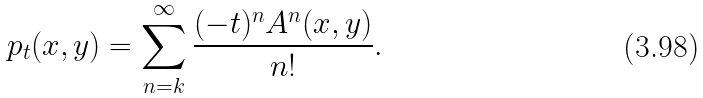Convert formula to latex. <formula><loc_0><loc_0><loc_500><loc_500>p _ { t } ( x , y ) = \sum _ { n = k } ^ { \infty } \frac { ( - t ) ^ { n } A ^ { n } ( x , y ) } { n ! } .</formula> 